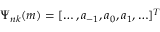Convert formula to latex. <formula><loc_0><loc_0><loc_500><loc_500>\Psi _ { n k } ( m ) = [ \dots , a _ { - 1 } , a _ { 0 } , a _ { 1 } , \dots ] ^ { T }</formula> 